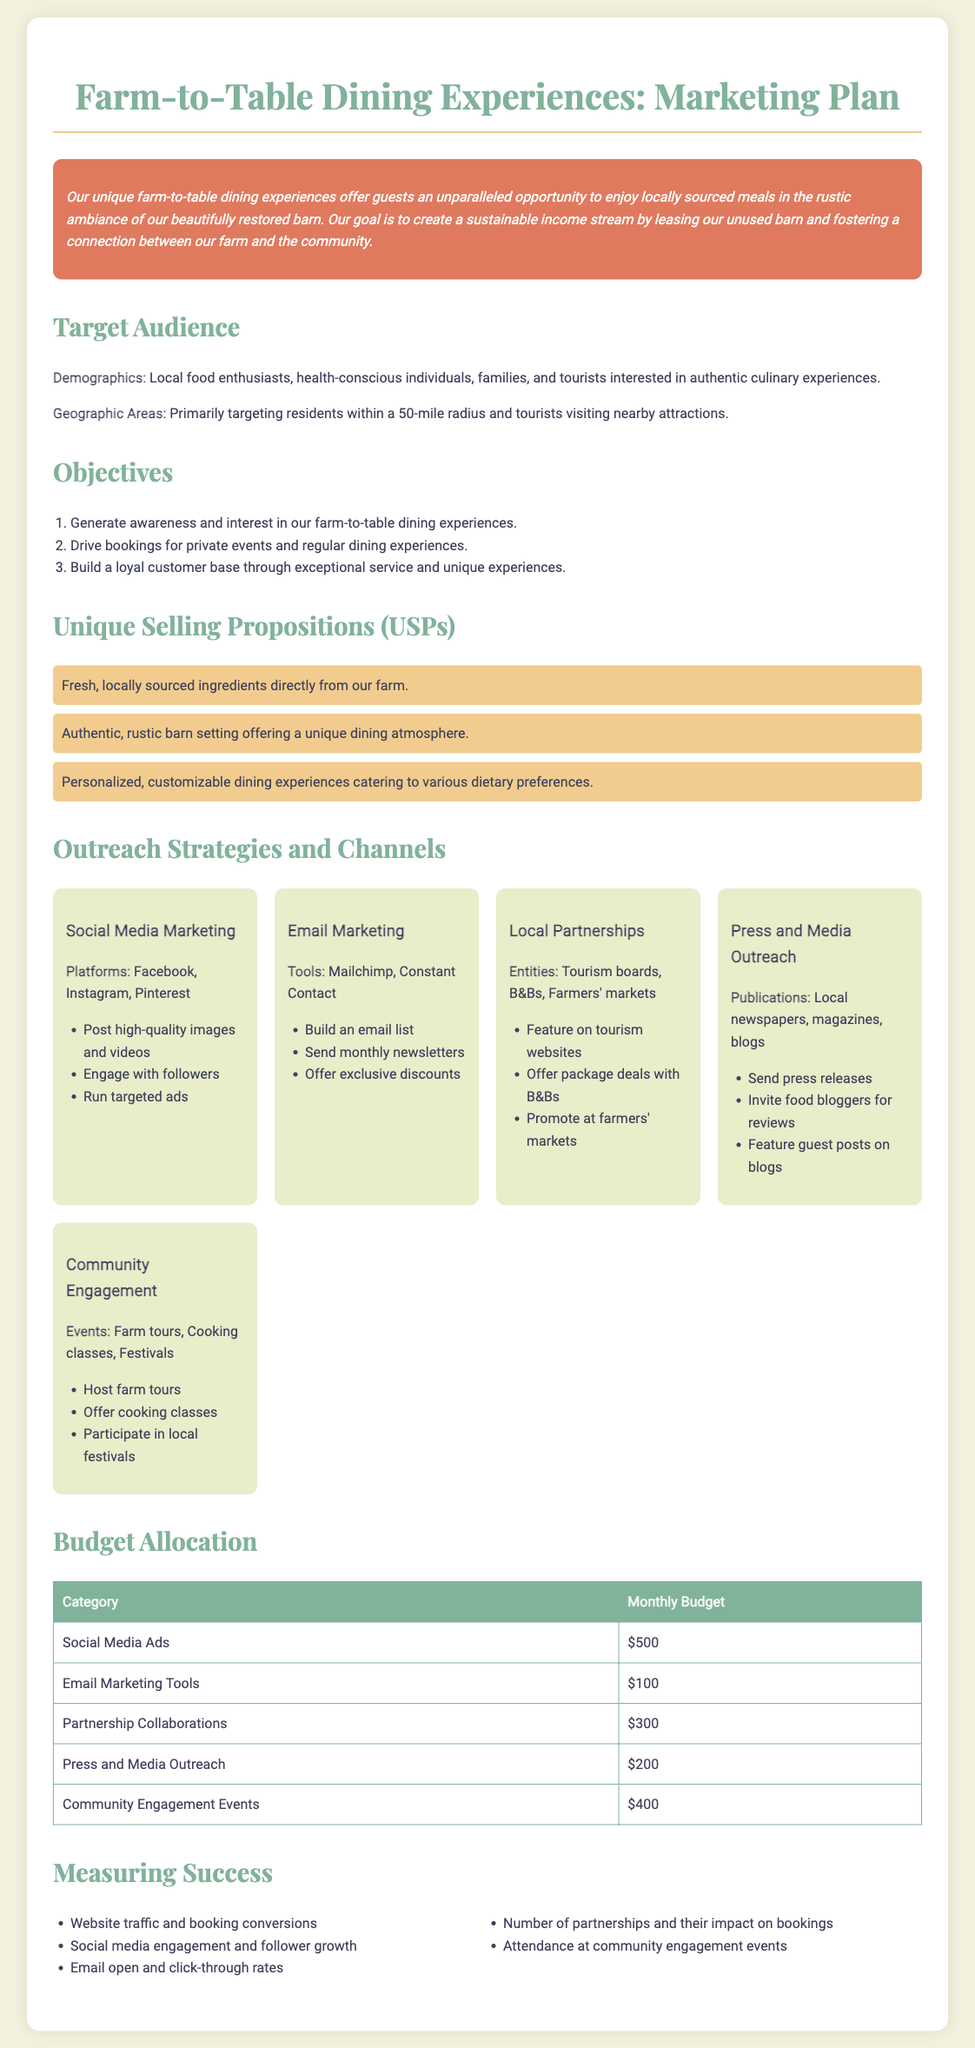What is the primary target audience? The primary target audience includes local food enthusiasts, health-conscious individuals, families, and tourists interested in authentic culinary experiences.
Answer: Local food enthusiasts, health-conscious individuals, families, and tourists What is the budget allocation for Social Media Ads? The document states that the budget allocation for Social Media Ads is outlined in the budget table.
Answer: $500 How many outreach strategies are listed in the document? The document lists five outreach strategies in the Outreach Strategies and Channels section.
Answer: 5 Which platforms are included in Social Media Marketing? The document specifies the platforms for Social Media Marketing.
Answer: Facebook, Instagram, Pinterest What is one of the objectives of the marketing plan? One of the objectives is to generate awareness and interest in farm-to-table dining experiences.
Answer: Generate awareness and interest How much is allocated for Community Engagement Events? The budget table provides information on the allocation for Community Engagement Events.
Answer: $400 What type of dining experience is being offered? The dining experience being offered emphasizes locally sourced meals in a unique ambiance.
Answer: Farm-to-table dining experiences Which marketing tool is listed for Email Marketing? The document mentions Mailchimp and Constant Contact as tools for Email Marketing.
Answer: Mailchimp, Constant Contact What is one method of community engagement mentioned? The document lists several methods for community engagement, including hosting events.
Answer: Host farm tours 